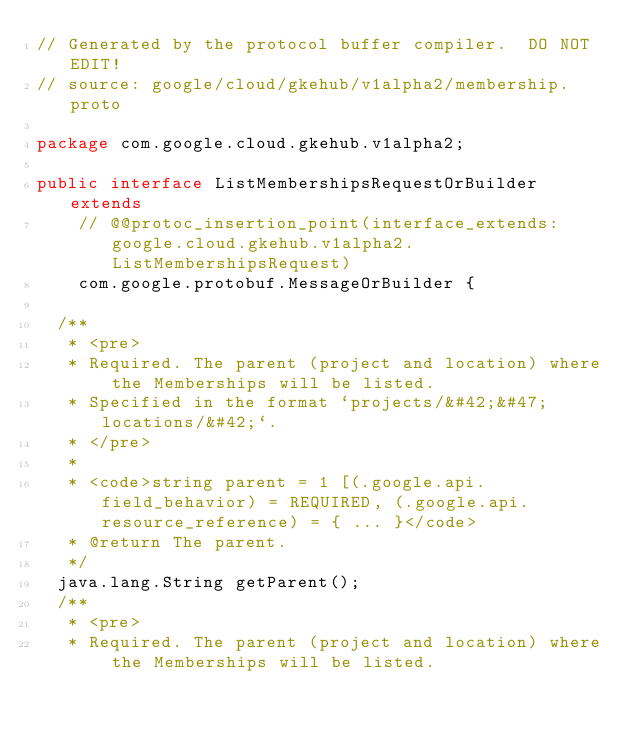<code> <loc_0><loc_0><loc_500><loc_500><_Java_>// Generated by the protocol buffer compiler.  DO NOT EDIT!
// source: google/cloud/gkehub/v1alpha2/membership.proto

package com.google.cloud.gkehub.v1alpha2;

public interface ListMembershipsRequestOrBuilder extends
    // @@protoc_insertion_point(interface_extends:google.cloud.gkehub.v1alpha2.ListMembershipsRequest)
    com.google.protobuf.MessageOrBuilder {

  /**
   * <pre>
   * Required. The parent (project and location) where the Memberships will be listed.
   * Specified in the format `projects/&#42;&#47;locations/&#42;`.
   * </pre>
   *
   * <code>string parent = 1 [(.google.api.field_behavior) = REQUIRED, (.google.api.resource_reference) = { ... }</code>
   * @return The parent.
   */
  java.lang.String getParent();
  /**
   * <pre>
   * Required. The parent (project and location) where the Memberships will be listed.</code> 